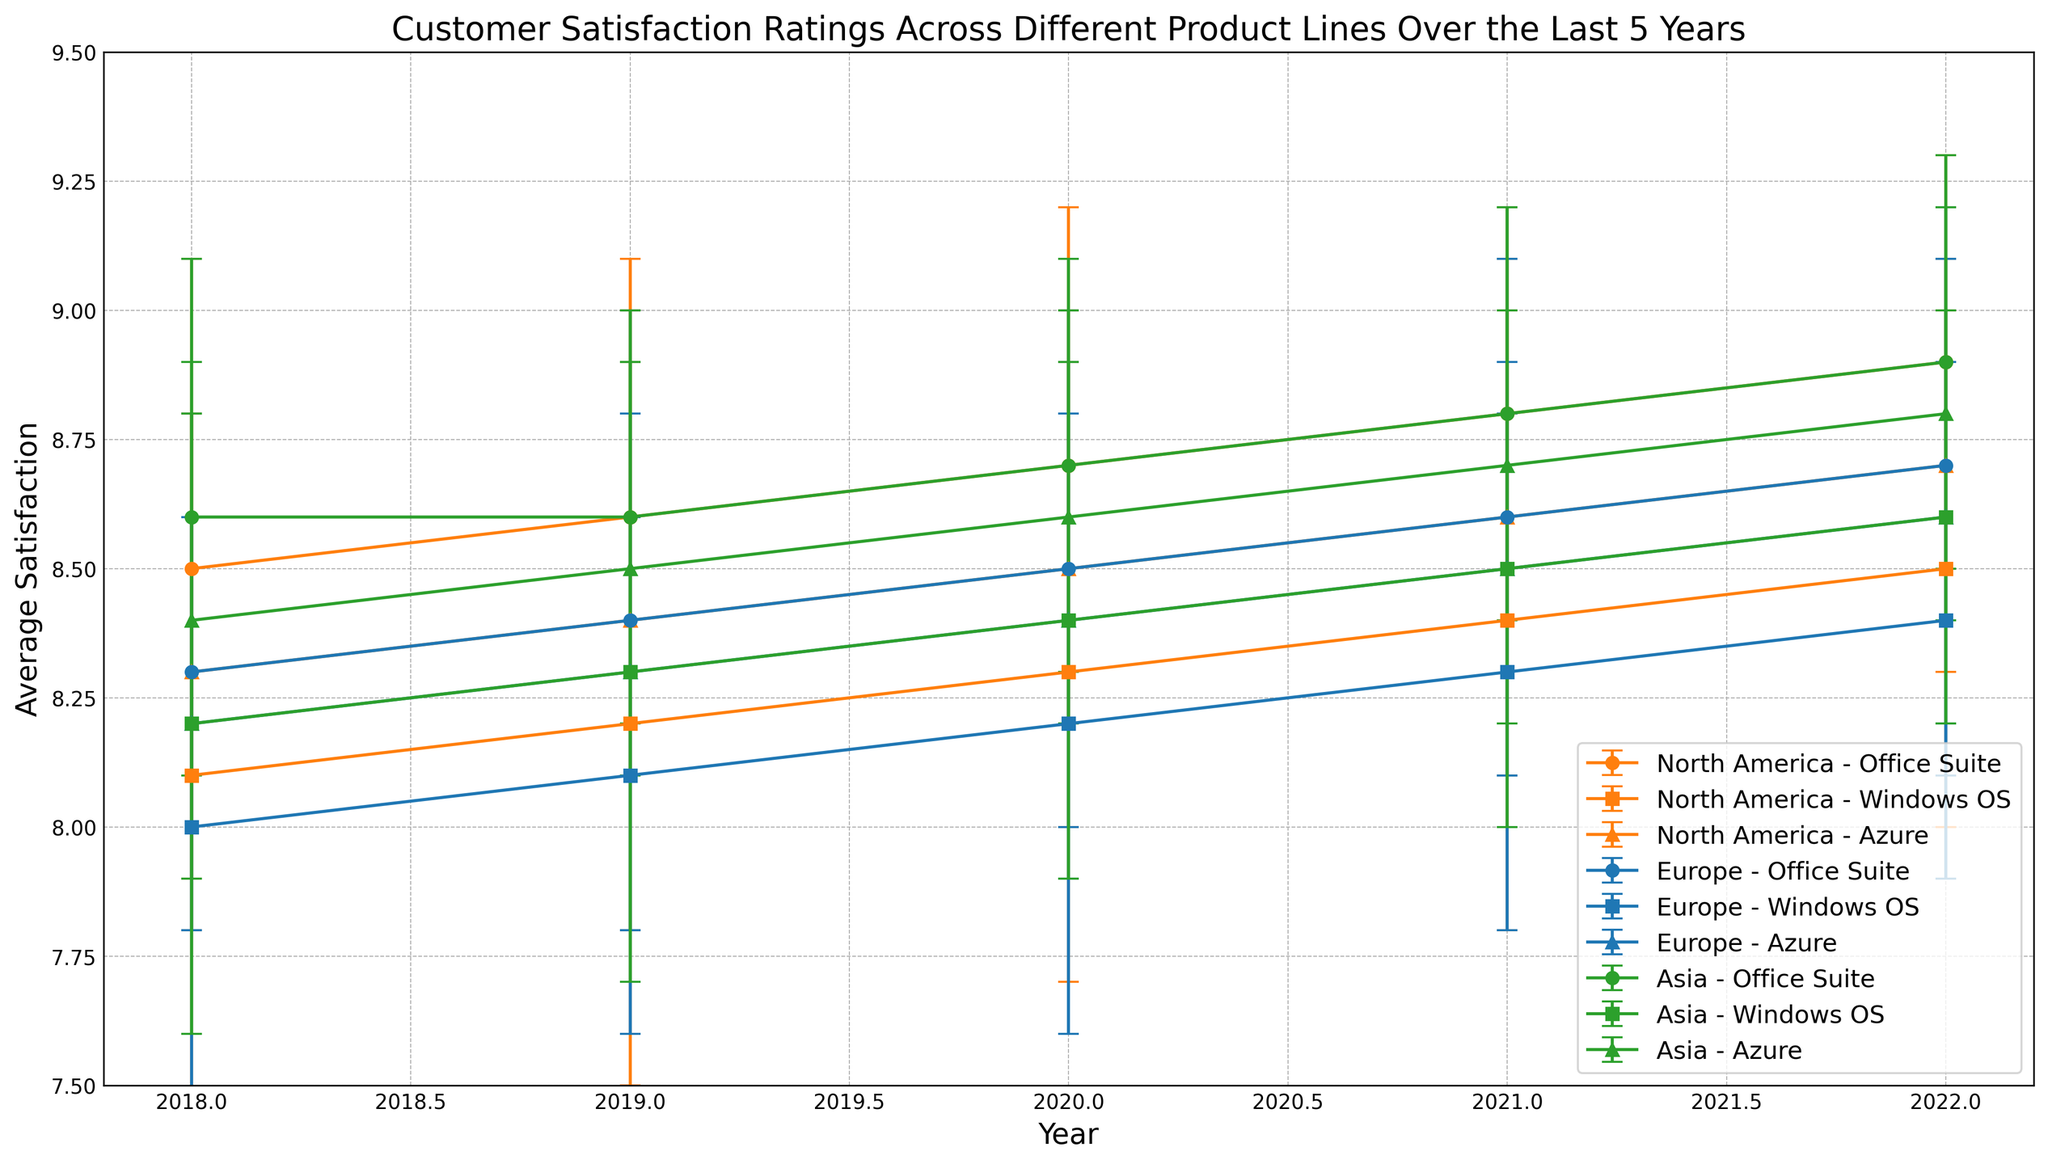What is the overall trend in customer satisfaction for the Office Suite product line across all regions from 2018 to 2022? To find the trend, observe the satisfaction ratings for the Office Suite over the years for all regions. Note if the values increase, decrease, or stay roughly constant. From 2018 to 2022, the ratings gradually increase across all regions.
Answer: Increasing Which region had the highest average satisfaction for Azure in 2022? Compare the satisfaction ratings for Azure in 2022 across all three regions. North America shows 8.7, Europe shows 8.6, and Asia shows 8.8, making Asia the region with the highest rating.
Answer: Asia Did Windows OS in Europe ever have a higher average satisfaction than in North America from 2018 to 2022? Evaluate the ratings for Windows OS in Europe and North America for each year. In 2018, 2019, 2020, 2021, and 2022, Europe's ratings were slightly lower or equal each time compared to North America. Thus, Europe never had a higher satisfaction for Windows OS than North America in these years.
Answer: No Between 2018 and 2022, how much did the average satisfaction for Azure increase in North America? Find the difference between the 2022 and 2018 values for Azure in North America. In 2018, it was 8.3. In 2022, it is 8.7. The increase is 8.7 - 8.3 = 0.4.
Answer: 0.4 Which product line shows the most consistent (the least variation) customer satisfaction in the Asia region over the years? To determine which product line has the most consistent satisfaction, compare the standard deviations for each product line in Asia. Office Suite: 0.5, 0.4, 0.4, 0.4, 0.4; Windows OS: 0.6, 0.6, 0.5, 0.5, 0.4; Azure: 0.5, 0.4, 0.4, 0.5, 0.4. All product lines have generally low deviation, but Office Suite and Azure have slightly lower average deviations.
Answer: Office Suite/Azure Which product line and region showed the greatest single-year increase in average satisfaction? Look for the steepest positive slope between consecutive years for each region's product lines. North America Office Suite shows the greatest increase from 2021 to 2022, from 8.8 to 8.9, increasing by 1.0.
Answer: North America Office Suite, 2021-2022 In 2020, which region-product combination had the highest average satisfaction, and what was the value? Compare all the satisfaction ratings across all regions and products in 2020. Office Suite in Asia has the highest rating of 8.7.
Answer: Asia Office Suite, 8.7 Looking at the error bars, which product line in Europe has the most uncertainty in 2021? Check the length of the error bars for each product line in Europe in 2021. Windows OS appears to have the longest error bars, meaning it has the highest standard deviation (0.5) and thus the most uncertainty.
Answer: Windows OS 